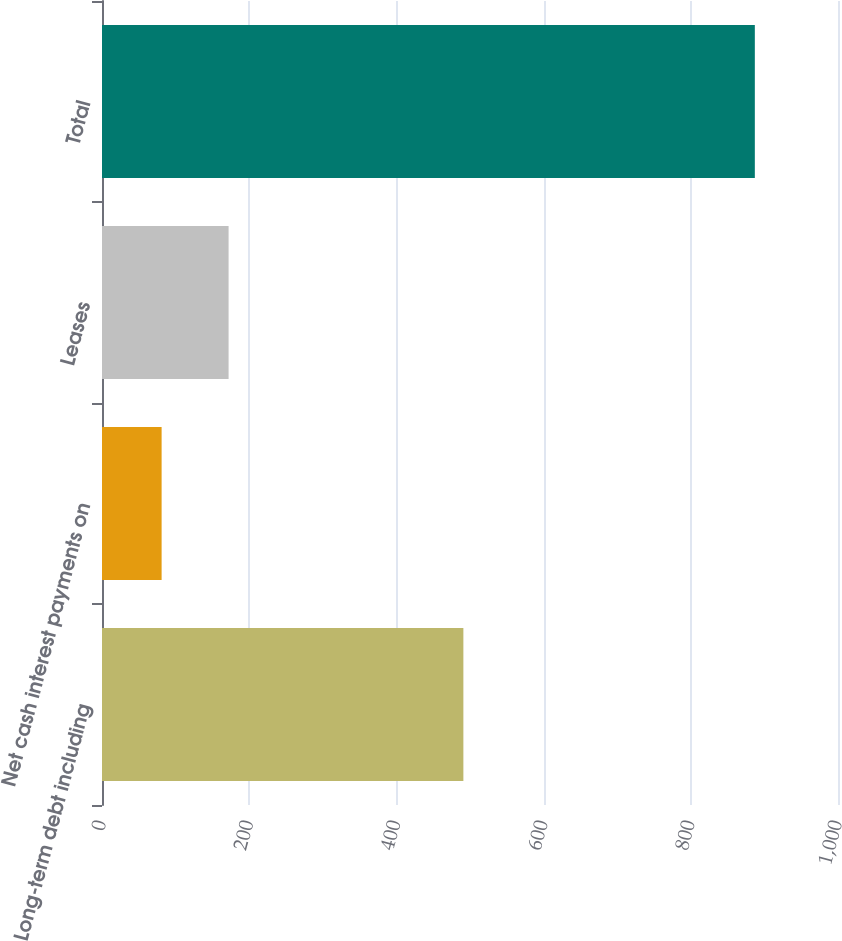<chart> <loc_0><loc_0><loc_500><loc_500><bar_chart><fcel>Long-term debt including<fcel>Net cash interest payments on<fcel>Leases<fcel>Total<nl><fcel>491<fcel>81<fcel>172<fcel>887<nl></chart> 